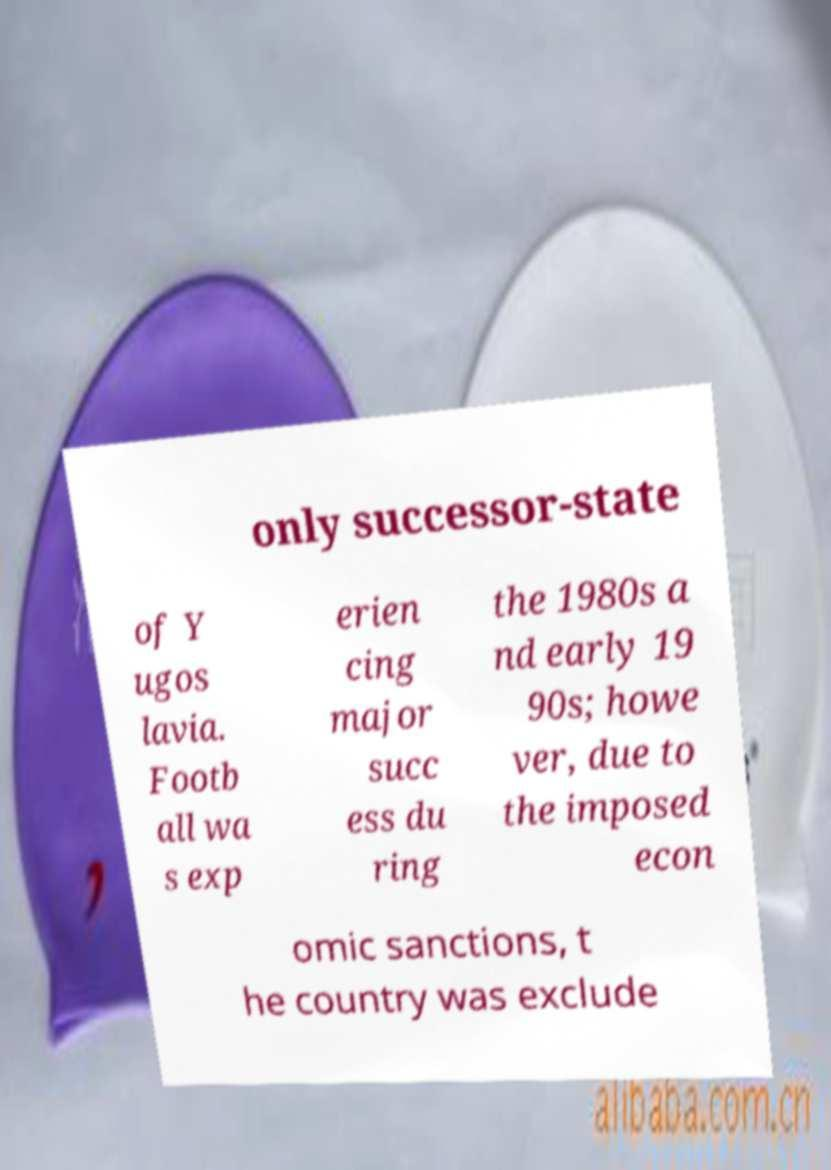Could you extract and type out the text from this image? only successor-state of Y ugos lavia. Footb all wa s exp erien cing major succ ess du ring the 1980s a nd early 19 90s; howe ver, due to the imposed econ omic sanctions, t he country was exclude 